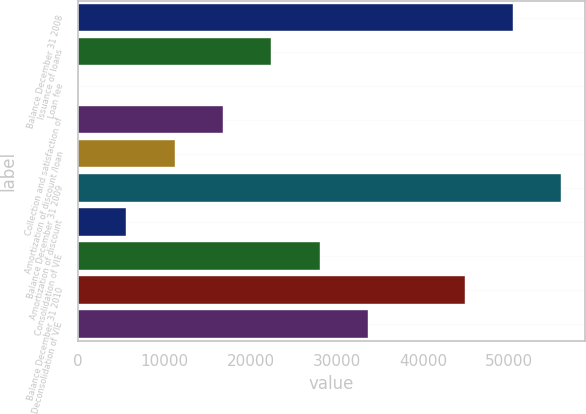Convert chart to OTSL. <chart><loc_0><loc_0><loc_500><loc_500><bar_chart><fcel>Balance December 31 2008<fcel>Issuance of loans<fcel>Loan fee<fcel>Collection and satisfaction of<fcel>Amortization of discount /loan<fcel>Balance December 31 2009<fcel>Amortization of discount<fcel>Consolidation of VIE<fcel>Balance December 31 2010<fcel>Deconsolidation of VIE<nl><fcel>50408.2<fcel>22395.8<fcel>15<fcel>16800.6<fcel>11205.4<fcel>56003.4<fcel>5610.2<fcel>27991<fcel>44813<fcel>33586.2<nl></chart> 